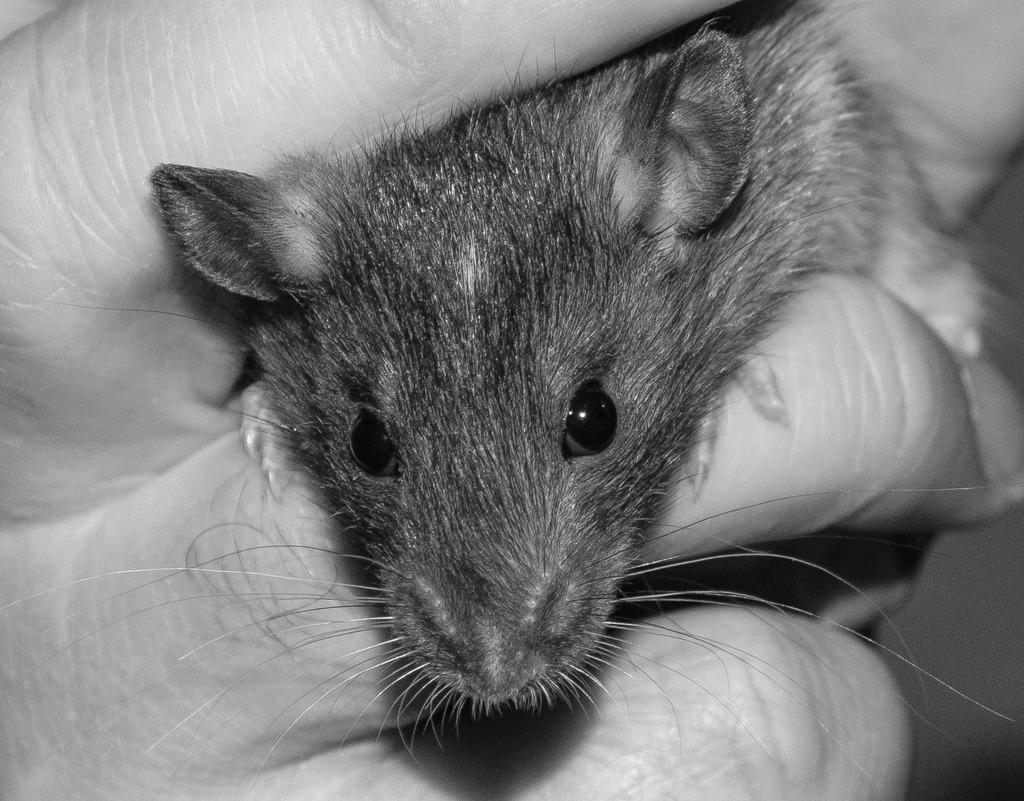What is the main subject of the image? There is a person in the image. What is the person holding in their hand? The person is holding a rat in their hand. What is the color scheme of the image? The image is black and white. What type of oil can be seen dripping from the person's hand in the image? There is no oil present in the image; the person is holding a rat. How many rabbits are visible in the image? There are no rabbits present in the image; the person is holding a rat. 